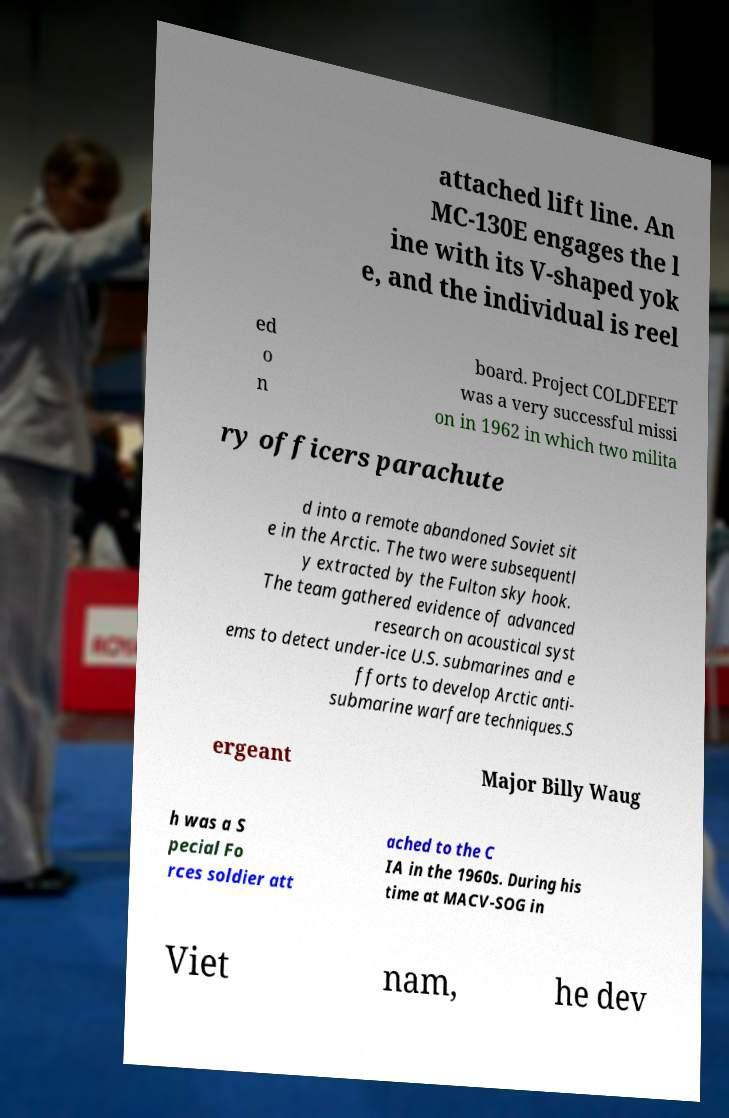There's text embedded in this image that I need extracted. Can you transcribe it verbatim? attached lift line. An MC-130E engages the l ine with its V-shaped yok e, and the individual is reel ed o n board. Project COLDFEET was a very successful missi on in 1962 in which two milita ry officers parachute d into a remote abandoned Soviet sit e in the Arctic. The two were subsequentl y extracted by the Fulton sky hook. The team gathered evidence of advanced research on acoustical syst ems to detect under-ice U.S. submarines and e fforts to develop Arctic anti- submarine warfare techniques.S ergeant Major Billy Waug h was a S pecial Fo rces soldier att ached to the C IA in the 1960s. During his time at MACV-SOG in Viet nam, he dev 